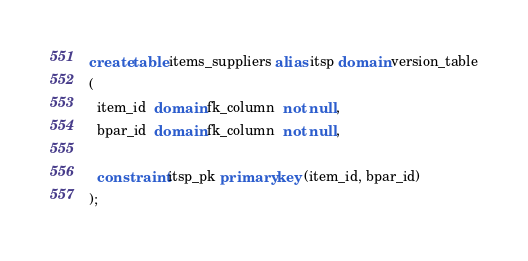<code> <loc_0><loc_0><loc_500><loc_500><_SQL_>create table items_suppliers alias itsp domain version_table
(
  item_id  domain fk_column  not null,
  bpar_id  domain fk_column  not null,

  constraint itsp_pk primary key (item_id, bpar_id)
);

</code> 